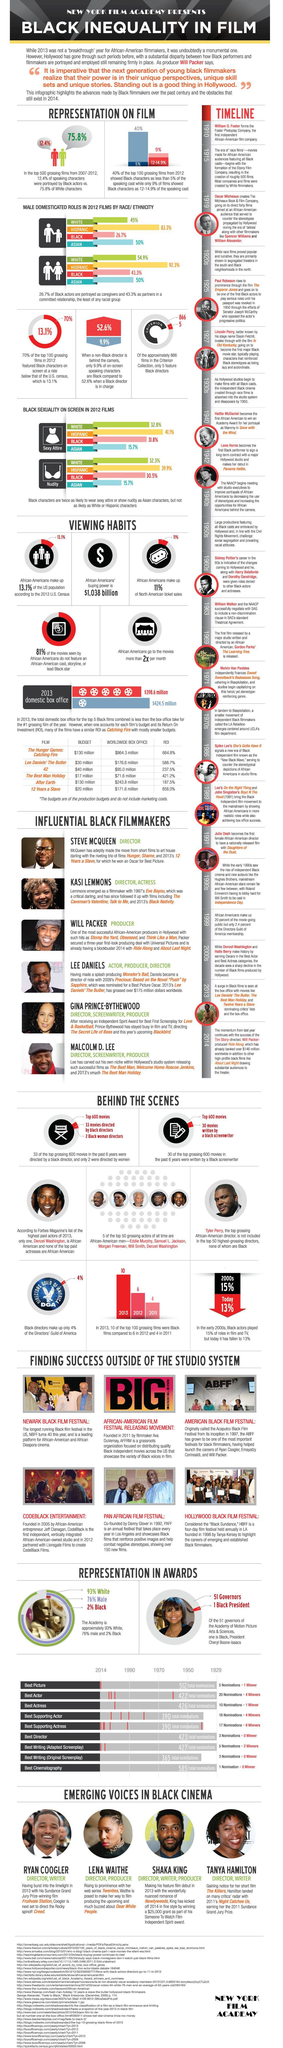Indicate a few pertinent items in this graphic. The percentage of black characters in movies directed by a black director is 52.6%. The film "Daughters of Dust" was released in 1991. According to the study, 92.3% of Hispanic actors portrayed as committed partners in film and television. In the year 1910, the Foster Photoplay company was formed. 